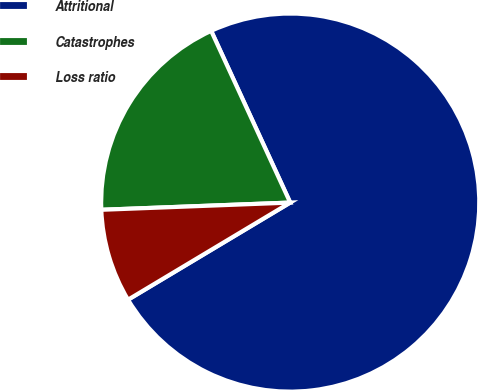<chart> <loc_0><loc_0><loc_500><loc_500><pie_chart><fcel>Attritional<fcel>Catastrophes<fcel>Loss ratio<nl><fcel>73.28%<fcel>18.74%<fcel>7.98%<nl></chart> 